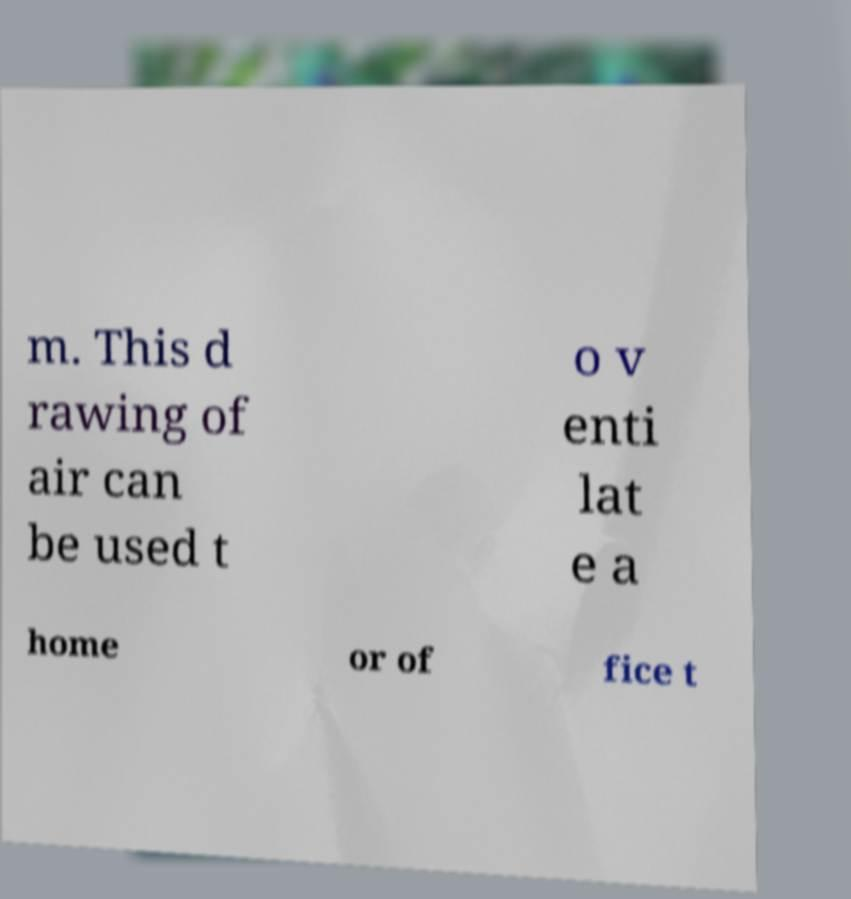What messages or text are displayed in this image? I need them in a readable, typed format. m. This d rawing of air can be used t o v enti lat e a home or of fice t 